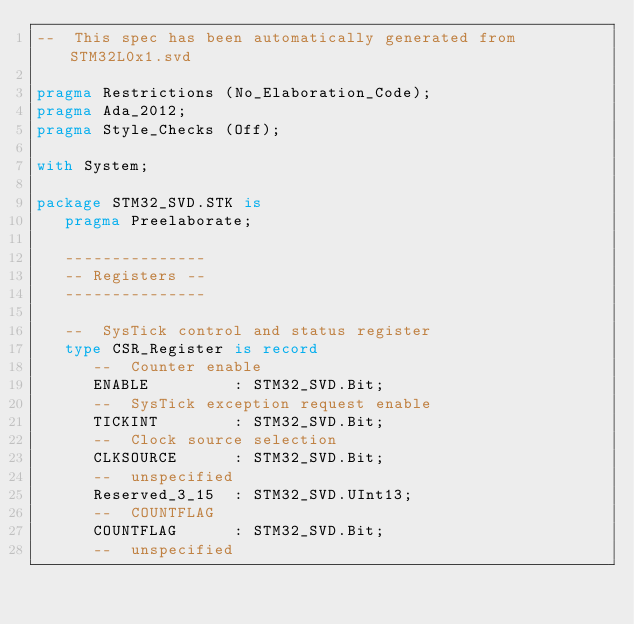Convert code to text. <code><loc_0><loc_0><loc_500><loc_500><_Ada_>--  This spec has been automatically generated from STM32L0x1.svd

pragma Restrictions (No_Elaboration_Code);
pragma Ada_2012;
pragma Style_Checks (Off);

with System;

package STM32_SVD.STK is
   pragma Preelaborate;

   ---------------
   -- Registers --
   ---------------

   --  SysTick control and status register
   type CSR_Register is record
      --  Counter enable
      ENABLE         : STM32_SVD.Bit;
      --  SysTick exception request enable
      TICKINT        : STM32_SVD.Bit;
      --  Clock source selection
      CLKSOURCE      : STM32_SVD.Bit;
      --  unspecified
      Reserved_3_15  : STM32_SVD.UInt13;
      --  COUNTFLAG
      COUNTFLAG      : STM32_SVD.Bit;
      --  unspecified</code> 